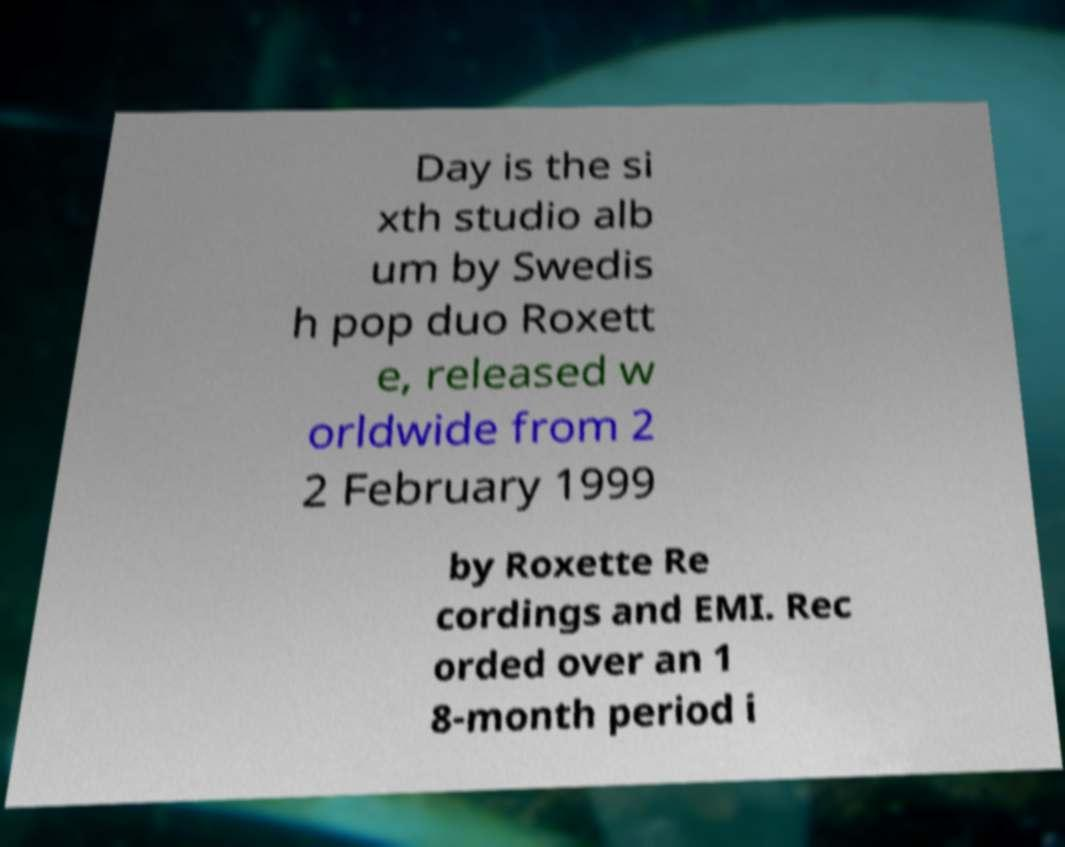For documentation purposes, I need the text within this image transcribed. Could you provide that? Day is the si xth studio alb um by Swedis h pop duo Roxett e, released w orldwide from 2 2 February 1999 by Roxette Re cordings and EMI. Rec orded over an 1 8-month period i 